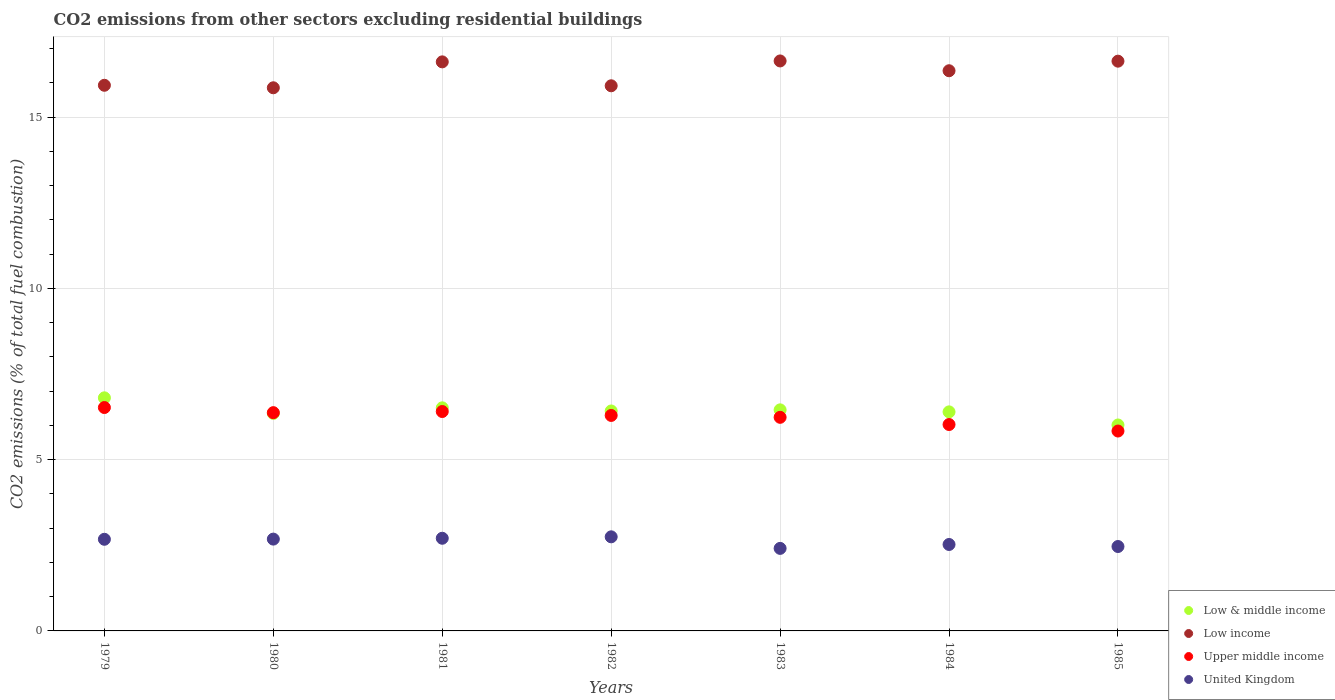How many different coloured dotlines are there?
Your answer should be very brief. 4. What is the total CO2 emitted in Low income in 1979?
Your response must be concise. 15.93. Across all years, what is the maximum total CO2 emitted in Upper middle income?
Your response must be concise. 6.52. Across all years, what is the minimum total CO2 emitted in Upper middle income?
Offer a very short reply. 5.84. In which year was the total CO2 emitted in Low & middle income maximum?
Keep it short and to the point. 1979. What is the total total CO2 emitted in United Kingdom in the graph?
Keep it short and to the point. 18.21. What is the difference between the total CO2 emitted in Low income in 1981 and that in 1985?
Offer a very short reply. -0.02. What is the difference between the total CO2 emitted in Low & middle income in 1983 and the total CO2 emitted in Low income in 1981?
Provide a succinct answer. -10.16. What is the average total CO2 emitted in Low income per year?
Offer a very short reply. 16.28. In the year 1985, what is the difference between the total CO2 emitted in Low income and total CO2 emitted in United Kingdom?
Your answer should be compact. 14.17. What is the ratio of the total CO2 emitted in United Kingdom in 1981 to that in 1983?
Provide a short and direct response. 1.12. Is the difference between the total CO2 emitted in Low income in 1980 and 1985 greater than the difference between the total CO2 emitted in United Kingdom in 1980 and 1985?
Provide a succinct answer. No. What is the difference between the highest and the second highest total CO2 emitted in Low income?
Ensure brevity in your answer.  0.01. What is the difference between the highest and the lowest total CO2 emitted in Low & middle income?
Offer a very short reply. 0.79. In how many years, is the total CO2 emitted in Low income greater than the average total CO2 emitted in Low income taken over all years?
Ensure brevity in your answer.  4. Is the sum of the total CO2 emitted in Low & middle income in 1980 and 1981 greater than the maximum total CO2 emitted in Low income across all years?
Provide a succinct answer. No. Does the total CO2 emitted in Low income monotonically increase over the years?
Provide a succinct answer. No. How many legend labels are there?
Give a very brief answer. 4. What is the title of the graph?
Provide a succinct answer. CO2 emissions from other sectors excluding residential buildings. Does "Croatia" appear as one of the legend labels in the graph?
Offer a very short reply. No. What is the label or title of the Y-axis?
Ensure brevity in your answer.  CO2 emissions (% of total fuel combustion). What is the CO2 emissions (% of total fuel combustion) of Low & middle income in 1979?
Ensure brevity in your answer.  6.81. What is the CO2 emissions (% of total fuel combustion) of Low income in 1979?
Your answer should be compact. 15.93. What is the CO2 emissions (% of total fuel combustion) of Upper middle income in 1979?
Your response must be concise. 6.52. What is the CO2 emissions (% of total fuel combustion) in United Kingdom in 1979?
Offer a terse response. 2.68. What is the CO2 emissions (% of total fuel combustion) of Low & middle income in 1980?
Give a very brief answer. 6.35. What is the CO2 emissions (% of total fuel combustion) of Low income in 1980?
Keep it short and to the point. 15.86. What is the CO2 emissions (% of total fuel combustion) of Upper middle income in 1980?
Keep it short and to the point. 6.37. What is the CO2 emissions (% of total fuel combustion) in United Kingdom in 1980?
Keep it short and to the point. 2.68. What is the CO2 emissions (% of total fuel combustion) in Low & middle income in 1981?
Your answer should be very brief. 6.51. What is the CO2 emissions (% of total fuel combustion) in Low income in 1981?
Offer a terse response. 16.62. What is the CO2 emissions (% of total fuel combustion) in Upper middle income in 1981?
Your answer should be very brief. 6.41. What is the CO2 emissions (% of total fuel combustion) of United Kingdom in 1981?
Offer a terse response. 2.71. What is the CO2 emissions (% of total fuel combustion) in Low & middle income in 1982?
Keep it short and to the point. 6.42. What is the CO2 emissions (% of total fuel combustion) in Low income in 1982?
Your response must be concise. 15.92. What is the CO2 emissions (% of total fuel combustion) in Upper middle income in 1982?
Your answer should be compact. 6.29. What is the CO2 emissions (% of total fuel combustion) of United Kingdom in 1982?
Provide a short and direct response. 2.75. What is the CO2 emissions (% of total fuel combustion) of Low & middle income in 1983?
Make the answer very short. 6.46. What is the CO2 emissions (% of total fuel combustion) in Low income in 1983?
Keep it short and to the point. 16.64. What is the CO2 emissions (% of total fuel combustion) of Upper middle income in 1983?
Make the answer very short. 6.24. What is the CO2 emissions (% of total fuel combustion) of United Kingdom in 1983?
Your answer should be compact. 2.41. What is the CO2 emissions (% of total fuel combustion) in Low & middle income in 1984?
Provide a short and direct response. 6.4. What is the CO2 emissions (% of total fuel combustion) of Low income in 1984?
Your answer should be compact. 16.36. What is the CO2 emissions (% of total fuel combustion) in Upper middle income in 1984?
Provide a succinct answer. 6.03. What is the CO2 emissions (% of total fuel combustion) of United Kingdom in 1984?
Your answer should be compact. 2.52. What is the CO2 emissions (% of total fuel combustion) in Low & middle income in 1985?
Your answer should be compact. 6.01. What is the CO2 emissions (% of total fuel combustion) in Low income in 1985?
Provide a succinct answer. 16.64. What is the CO2 emissions (% of total fuel combustion) in Upper middle income in 1985?
Provide a short and direct response. 5.84. What is the CO2 emissions (% of total fuel combustion) in United Kingdom in 1985?
Make the answer very short. 2.46. Across all years, what is the maximum CO2 emissions (% of total fuel combustion) in Low & middle income?
Provide a short and direct response. 6.81. Across all years, what is the maximum CO2 emissions (% of total fuel combustion) in Low income?
Provide a short and direct response. 16.64. Across all years, what is the maximum CO2 emissions (% of total fuel combustion) of Upper middle income?
Offer a terse response. 6.52. Across all years, what is the maximum CO2 emissions (% of total fuel combustion) in United Kingdom?
Your answer should be very brief. 2.75. Across all years, what is the minimum CO2 emissions (% of total fuel combustion) of Low & middle income?
Your response must be concise. 6.01. Across all years, what is the minimum CO2 emissions (% of total fuel combustion) of Low income?
Provide a succinct answer. 15.86. Across all years, what is the minimum CO2 emissions (% of total fuel combustion) of Upper middle income?
Make the answer very short. 5.84. Across all years, what is the minimum CO2 emissions (% of total fuel combustion) of United Kingdom?
Make the answer very short. 2.41. What is the total CO2 emissions (% of total fuel combustion) in Low & middle income in the graph?
Your answer should be compact. 44.96. What is the total CO2 emissions (% of total fuel combustion) of Low income in the graph?
Ensure brevity in your answer.  113.96. What is the total CO2 emissions (% of total fuel combustion) of Upper middle income in the graph?
Your answer should be very brief. 43.69. What is the total CO2 emissions (% of total fuel combustion) in United Kingdom in the graph?
Your answer should be very brief. 18.21. What is the difference between the CO2 emissions (% of total fuel combustion) in Low & middle income in 1979 and that in 1980?
Your response must be concise. 0.45. What is the difference between the CO2 emissions (% of total fuel combustion) of Low income in 1979 and that in 1980?
Your response must be concise. 0.07. What is the difference between the CO2 emissions (% of total fuel combustion) in Upper middle income in 1979 and that in 1980?
Provide a short and direct response. 0.15. What is the difference between the CO2 emissions (% of total fuel combustion) in United Kingdom in 1979 and that in 1980?
Give a very brief answer. -0.01. What is the difference between the CO2 emissions (% of total fuel combustion) in Low & middle income in 1979 and that in 1981?
Offer a terse response. 0.29. What is the difference between the CO2 emissions (% of total fuel combustion) in Low income in 1979 and that in 1981?
Your answer should be compact. -0.68. What is the difference between the CO2 emissions (% of total fuel combustion) of Upper middle income in 1979 and that in 1981?
Offer a terse response. 0.12. What is the difference between the CO2 emissions (% of total fuel combustion) in United Kingdom in 1979 and that in 1981?
Provide a short and direct response. -0.03. What is the difference between the CO2 emissions (% of total fuel combustion) of Low & middle income in 1979 and that in 1982?
Offer a terse response. 0.38. What is the difference between the CO2 emissions (% of total fuel combustion) in Low income in 1979 and that in 1982?
Provide a short and direct response. 0.01. What is the difference between the CO2 emissions (% of total fuel combustion) of Upper middle income in 1979 and that in 1982?
Offer a terse response. 0.23. What is the difference between the CO2 emissions (% of total fuel combustion) of United Kingdom in 1979 and that in 1982?
Provide a succinct answer. -0.07. What is the difference between the CO2 emissions (% of total fuel combustion) of Low & middle income in 1979 and that in 1983?
Provide a succinct answer. 0.35. What is the difference between the CO2 emissions (% of total fuel combustion) of Low income in 1979 and that in 1983?
Give a very brief answer. -0.71. What is the difference between the CO2 emissions (% of total fuel combustion) of Upper middle income in 1979 and that in 1983?
Your response must be concise. 0.29. What is the difference between the CO2 emissions (% of total fuel combustion) in United Kingdom in 1979 and that in 1983?
Offer a terse response. 0.27. What is the difference between the CO2 emissions (% of total fuel combustion) in Low & middle income in 1979 and that in 1984?
Your answer should be compact. 0.41. What is the difference between the CO2 emissions (% of total fuel combustion) in Low income in 1979 and that in 1984?
Offer a very short reply. -0.42. What is the difference between the CO2 emissions (% of total fuel combustion) of Upper middle income in 1979 and that in 1984?
Provide a succinct answer. 0.5. What is the difference between the CO2 emissions (% of total fuel combustion) of United Kingdom in 1979 and that in 1984?
Make the answer very short. 0.15. What is the difference between the CO2 emissions (% of total fuel combustion) in Low & middle income in 1979 and that in 1985?
Offer a terse response. 0.79. What is the difference between the CO2 emissions (% of total fuel combustion) in Low income in 1979 and that in 1985?
Offer a terse response. -0.7. What is the difference between the CO2 emissions (% of total fuel combustion) of Upper middle income in 1979 and that in 1985?
Provide a succinct answer. 0.69. What is the difference between the CO2 emissions (% of total fuel combustion) in United Kingdom in 1979 and that in 1985?
Provide a short and direct response. 0.21. What is the difference between the CO2 emissions (% of total fuel combustion) of Low & middle income in 1980 and that in 1981?
Ensure brevity in your answer.  -0.16. What is the difference between the CO2 emissions (% of total fuel combustion) of Low income in 1980 and that in 1981?
Your answer should be compact. -0.76. What is the difference between the CO2 emissions (% of total fuel combustion) in Upper middle income in 1980 and that in 1981?
Make the answer very short. -0.03. What is the difference between the CO2 emissions (% of total fuel combustion) of United Kingdom in 1980 and that in 1981?
Keep it short and to the point. -0.02. What is the difference between the CO2 emissions (% of total fuel combustion) of Low & middle income in 1980 and that in 1982?
Keep it short and to the point. -0.07. What is the difference between the CO2 emissions (% of total fuel combustion) of Low income in 1980 and that in 1982?
Offer a very short reply. -0.06. What is the difference between the CO2 emissions (% of total fuel combustion) in Upper middle income in 1980 and that in 1982?
Give a very brief answer. 0.08. What is the difference between the CO2 emissions (% of total fuel combustion) of United Kingdom in 1980 and that in 1982?
Give a very brief answer. -0.07. What is the difference between the CO2 emissions (% of total fuel combustion) of Low & middle income in 1980 and that in 1983?
Offer a terse response. -0.1. What is the difference between the CO2 emissions (% of total fuel combustion) of Low income in 1980 and that in 1983?
Your response must be concise. -0.78. What is the difference between the CO2 emissions (% of total fuel combustion) of Upper middle income in 1980 and that in 1983?
Your answer should be compact. 0.14. What is the difference between the CO2 emissions (% of total fuel combustion) of United Kingdom in 1980 and that in 1983?
Offer a terse response. 0.27. What is the difference between the CO2 emissions (% of total fuel combustion) in Low & middle income in 1980 and that in 1984?
Give a very brief answer. -0.04. What is the difference between the CO2 emissions (% of total fuel combustion) in Low income in 1980 and that in 1984?
Your response must be concise. -0.5. What is the difference between the CO2 emissions (% of total fuel combustion) in Upper middle income in 1980 and that in 1984?
Give a very brief answer. 0.35. What is the difference between the CO2 emissions (% of total fuel combustion) in United Kingdom in 1980 and that in 1984?
Ensure brevity in your answer.  0.16. What is the difference between the CO2 emissions (% of total fuel combustion) of Low & middle income in 1980 and that in 1985?
Your answer should be compact. 0.34. What is the difference between the CO2 emissions (% of total fuel combustion) of Low income in 1980 and that in 1985?
Ensure brevity in your answer.  -0.78. What is the difference between the CO2 emissions (% of total fuel combustion) in Upper middle income in 1980 and that in 1985?
Ensure brevity in your answer.  0.54. What is the difference between the CO2 emissions (% of total fuel combustion) in United Kingdom in 1980 and that in 1985?
Make the answer very short. 0.22. What is the difference between the CO2 emissions (% of total fuel combustion) in Low & middle income in 1981 and that in 1982?
Offer a terse response. 0.09. What is the difference between the CO2 emissions (% of total fuel combustion) in Low income in 1981 and that in 1982?
Give a very brief answer. 0.7. What is the difference between the CO2 emissions (% of total fuel combustion) in Upper middle income in 1981 and that in 1982?
Your answer should be very brief. 0.11. What is the difference between the CO2 emissions (% of total fuel combustion) in United Kingdom in 1981 and that in 1982?
Keep it short and to the point. -0.04. What is the difference between the CO2 emissions (% of total fuel combustion) of Low & middle income in 1981 and that in 1983?
Provide a succinct answer. 0.06. What is the difference between the CO2 emissions (% of total fuel combustion) in Low income in 1981 and that in 1983?
Give a very brief answer. -0.03. What is the difference between the CO2 emissions (% of total fuel combustion) in Upper middle income in 1981 and that in 1983?
Make the answer very short. 0.17. What is the difference between the CO2 emissions (% of total fuel combustion) in United Kingdom in 1981 and that in 1983?
Give a very brief answer. 0.3. What is the difference between the CO2 emissions (% of total fuel combustion) of Low & middle income in 1981 and that in 1984?
Offer a terse response. 0.12. What is the difference between the CO2 emissions (% of total fuel combustion) in Low income in 1981 and that in 1984?
Provide a succinct answer. 0.26. What is the difference between the CO2 emissions (% of total fuel combustion) in Upper middle income in 1981 and that in 1984?
Provide a succinct answer. 0.38. What is the difference between the CO2 emissions (% of total fuel combustion) of United Kingdom in 1981 and that in 1984?
Your response must be concise. 0.18. What is the difference between the CO2 emissions (% of total fuel combustion) of Low & middle income in 1981 and that in 1985?
Provide a succinct answer. 0.5. What is the difference between the CO2 emissions (% of total fuel combustion) in Low income in 1981 and that in 1985?
Your response must be concise. -0.02. What is the difference between the CO2 emissions (% of total fuel combustion) in Upper middle income in 1981 and that in 1985?
Your answer should be compact. 0.57. What is the difference between the CO2 emissions (% of total fuel combustion) in United Kingdom in 1981 and that in 1985?
Offer a terse response. 0.24. What is the difference between the CO2 emissions (% of total fuel combustion) in Low & middle income in 1982 and that in 1983?
Provide a succinct answer. -0.03. What is the difference between the CO2 emissions (% of total fuel combustion) in Low income in 1982 and that in 1983?
Provide a succinct answer. -0.73. What is the difference between the CO2 emissions (% of total fuel combustion) in Upper middle income in 1982 and that in 1983?
Make the answer very short. 0.06. What is the difference between the CO2 emissions (% of total fuel combustion) of United Kingdom in 1982 and that in 1983?
Offer a very short reply. 0.34. What is the difference between the CO2 emissions (% of total fuel combustion) of Low & middle income in 1982 and that in 1984?
Give a very brief answer. 0.03. What is the difference between the CO2 emissions (% of total fuel combustion) of Low income in 1982 and that in 1984?
Provide a short and direct response. -0.44. What is the difference between the CO2 emissions (% of total fuel combustion) of Upper middle income in 1982 and that in 1984?
Provide a short and direct response. 0.27. What is the difference between the CO2 emissions (% of total fuel combustion) in United Kingdom in 1982 and that in 1984?
Provide a succinct answer. 0.22. What is the difference between the CO2 emissions (% of total fuel combustion) of Low & middle income in 1982 and that in 1985?
Offer a very short reply. 0.41. What is the difference between the CO2 emissions (% of total fuel combustion) in Low income in 1982 and that in 1985?
Your answer should be very brief. -0.72. What is the difference between the CO2 emissions (% of total fuel combustion) in Upper middle income in 1982 and that in 1985?
Give a very brief answer. 0.46. What is the difference between the CO2 emissions (% of total fuel combustion) in United Kingdom in 1982 and that in 1985?
Provide a short and direct response. 0.28. What is the difference between the CO2 emissions (% of total fuel combustion) in Low & middle income in 1983 and that in 1984?
Your answer should be very brief. 0.06. What is the difference between the CO2 emissions (% of total fuel combustion) in Low income in 1983 and that in 1984?
Keep it short and to the point. 0.29. What is the difference between the CO2 emissions (% of total fuel combustion) of Upper middle income in 1983 and that in 1984?
Make the answer very short. 0.21. What is the difference between the CO2 emissions (% of total fuel combustion) of United Kingdom in 1983 and that in 1984?
Make the answer very short. -0.11. What is the difference between the CO2 emissions (% of total fuel combustion) in Low & middle income in 1983 and that in 1985?
Give a very brief answer. 0.44. What is the difference between the CO2 emissions (% of total fuel combustion) of Low income in 1983 and that in 1985?
Provide a short and direct response. 0.01. What is the difference between the CO2 emissions (% of total fuel combustion) in Upper middle income in 1983 and that in 1985?
Offer a terse response. 0.4. What is the difference between the CO2 emissions (% of total fuel combustion) in United Kingdom in 1983 and that in 1985?
Offer a very short reply. -0.05. What is the difference between the CO2 emissions (% of total fuel combustion) of Low & middle income in 1984 and that in 1985?
Provide a succinct answer. 0.38. What is the difference between the CO2 emissions (% of total fuel combustion) of Low income in 1984 and that in 1985?
Keep it short and to the point. -0.28. What is the difference between the CO2 emissions (% of total fuel combustion) of Upper middle income in 1984 and that in 1985?
Provide a short and direct response. 0.19. What is the difference between the CO2 emissions (% of total fuel combustion) of United Kingdom in 1984 and that in 1985?
Keep it short and to the point. 0.06. What is the difference between the CO2 emissions (% of total fuel combustion) of Low & middle income in 1979 and the CO2 emissions (% of total fuel combustion) of Low income in 1980?
Make the answer very short. -9.05. What is the difference between the CO2 emissions (% of total fuel combustion) of Low & middle income in 1979 and the CO2 emissions (% of total fuel combustion) of Upper middle income in 1980?
Your answer should be compact. 0.43. What is the difference between the CO2 emissions (% of total fuel combustion) of Low & middle income in 1979 and the CO2 emissions (% of total fuel combustion) of United Kingdom in 1980?
Your answer should be compact. 4.13. What is the difference between the CO2 emissions (% of total fuel combustion) in Low income in 1979 and the CO2 emissions (% of total fuel combustion) in Upper middle income in 1980?
Give a very brief answer. 9.56. What is the difference between the CO2 emissions (% of total fuel combustion) of Low income in 1979 and the CO2 emissions (% of total fuel combustion) of United Kingdom in 1980?
Ensure brevity in your answer.  13.25. What is the difference between the CO2 emissions (% of total fuel combustion) in Upper middle income in 1979 and the CO2 emissions (% of total fuel combustion) in United Kingdom in 1980?
Give a very brief answer. 3.84. What is the difference between the CO2 emissions (% of total fuel combustion) of Low & middle income in 1979 and the CO2 emissions (% of total fuel combustion) of Low income in 1981?
Your answer should be compact. -9.81. What is the difference between the CO2 emissions (% of total fuel combustion) in Low & middle income in 1979 and the CO2 emissions (% of total fuel combustion) in Upper middle income in 1981?
Keep it short and to the point. 0.4. What is the difference between the CO2 emissions (% of total fuel combustion) of Low & middle income in 1979 and the CO2 emissions (% of total fuel combustion) of United Kingdom in 1981?
Keep it short and to the point. 4.1. What is the difference between the CO2 emissions (% of total fuel combustion) in Low income in 1979 and the CO2 emissions (% of total fuel combustion) in Upper middle income in 1981?
Give a very brief answer. 9.53. What is the difference between the CO2 emissions (% of total fuel combustion) of Low income in 1979 and the CO2 emissions (% of total fuel combustion) of United Kingdom in 1981?
Your answer should be compact. 13.23. What is the difference between the CO2 emissions (% of total fuel combustion) of Upper middle income in 1979 and the CO2 emissions (% of total fuel combustion) of United Kingdom in 1981?
Offer a very short reply. 3.82. What is the difference between the CO2 emissions (% of total fuel combustion) of Low & middle income in 1979 and the CO2 emissions (% of total fuel combustion) of Low income in 1982?
Provide a short and direct response. -9.11. What is the difference between the CO2 emissions (% of total fuel combustion) in Low & middle income in 1979 and the CO2 emissions (% of total fuel combustion) in Upper middle income in 1982?
Keep it short and to the point. 0.51. What is the difference between the CO2 emissions (% of total fuel combustion) of Low & middle income in 1979 and the CO2 emissions (% of total fuel combustion) of United Kingdom in 1982?
Provide a succinct answer. 4.06. What is the difference between the CO2 emissions (% of total fuel combustion) of Low income in 1979 and the CO2 emissions (% of total fuel combustion) of Upper middle income in 1982?
Offer a terse response. 9.64. What is the difference between the CO2 emissions (% of total fuel combustion) of Low income in 1979 and the CO2 emissions (% of total fuel combustion) of United Kingdom in 1982?
Provide a succinct answer. 13.18. What is the difference between the CO2 emissions (% of total fuel combustion) in Upper middle income in 1979 and the CO2 emissions (% of total fuel combustion) in United Kingdom in 1982?
Your answer should be compact. 3.78. What is the difference between the CO2 emissions (% of total fuel combustion) in Low & middle income in 1979 and the CO2 emissions (% of total fuel combustion) in Low income in 1983?
Your answer should be compact. -9.84. What is the difference between the CO2 emissions (% of total fuel combustion) of Low & middle income in 1979 and the CO2 emissions (% of total fuel combustion) of Upper middle income in 1983?
Your response must be concise. 0.57. What is the difference between the CO2 emissions (% of total fuel combustion) of Low & middle income in 1979 and the CO2 emissions (% of total fuel combustion) of United Kingdom in 1983?
Your answer should be compact. 4.4. What is the difference between the CO2 emissions (% of total fuel combustion) of Low income in 1979 and the CO2 emissions (% of total fuel combustion) of Upper middle income in 1983?
Provide a succinct answer. 9.7. What is the difference between the CO2 emissions (% of total fuel combustion) of Low income in 1979 and the CO2 emissions (% of total fuel combustion) of United Kingdom in 1983?
Offer a terse response. 13.52. What is the difference between the CO2 emissions (% of total fuel combustion) in Upper middle income in 1979 and the CO2 emissions (% of total fuel combustion) in United Kingdom in 1983?
Your answer should be compact. 4.11. What is the difference between the CO2 emissions (% of total fuel combustion) in Low & middle income in 1979 and the CO2 emissions (% of total fuel combustion) in Low income in 1984?
Keep it short and to the point. -9.55. What is the difference between the CO2 emissions (% of total fuel combustion) of Low & middle income in 1979 and the CO2 emissions (% of total fuel combustion) of Upper middle income in 1984?
Provide a short and direct response. 0.78. What is the difference between the CO2 emissions (% of total fuel combustion) in Low & middle income in 1979 and the CO2 emissions (% of total fuel combustion) in United Kingdom in 1984?
Your response must be concise. 4.28. What is the difference between the CO2 emissions (% of total fuel combustion) in Low income in 1979 and the CO2 emissions (% of total fuel combustion) in Upper middle income in 1984?
Offer a terse response. 9.91. What is the difference between the CO2 emissions (% of total fuel combustion) in Low income in 1979 and the CO2 emissions (% of total fuel combustion) in United Kingdom in 1984?
Provide a short and direct response. 13.41. What is the difference between the CO2 emissions (% of total fuel combustion) in Upper middle income in 1979 and the CO2 emissions (% of total fuel combustion) in United Kingdom in 1984?
Offer a terse response. 4. What is the difference between the CO2 emissions (% of total fuel combustion) in Low & middle income in 1979 and the CO2 emissions (% of total fuel combustion) in Low income in 1985?
Make the answer very short. -9.83. What is the difference between the CO2 emissions (% of total fuel combustion) of Low & middle income in 1979 and the CO2 emissions (% of total fuel combustion) of Upper middle income in 1985?
Keep it short and to the point. 0.97. What is the difference between the CO2 emissions (% of total fuel combustion) of Low & middle income in 1979 and the CO2 emissions (% of total fuel combustion) of United Kingdom in 1985?
Offer a very short reply. 4.34. What is the difference between the CO2 emissions (% of total fuel combustion) in Low income in 1979 and the CO2 emissions (% of total fuel combustion) in Upper middle income in 1985?
Offer a very short reply. 10.1. What is the difference between the CO2 emissions (% of total fuel combustion) of Low income in 1979 and the CO2 emissions (% of total fuel combustion) of United Kingdom in 1985?
Keep it short and to the point. 13.47. What is the difference between the CO2 emissions (% of total fuel combustion) in Upper middle income in 1979 and the CO2 emissions (% of total fuel combustion) in United Kingdom in 1985?
Make the answer very short. 4.06. What is the difference between the CO2 emissions (% of total fuel combustion) of Low & middle income in 1980 and the CO2 emissions (% of total fuel combustion) of Low income in 1981?
Your response must be concise. -10.26. What is the difference between the CO2 emissions (% of total fuel combustion) of Low & middle income in 1980 and the CO2 emissions (% of total fuel combustion) of Upper middle income in 1981?
Give a very brief answer. -0.05. What is the difference between the CO2 emissions (% of total fuel combustion) of Low & middle income in 1980 and the CO2 emissions (% of total fuel combustion) of United Kingdom in 1981?
Provide a short and direct response. 3.65. What is the difference between the CO2 emissions (% of total fuel combustion) of Low income in 1980 and the CO2 emissions (% of total fuel combustion) of Upper middle income in 1981?
Your answer should be compact. 9.45. What is the difference between the CO2 emissions (% of total fuel combustion) in Low income in 1980 and the CO2 emissions (% of total fuel combustion) in United Kingdom in 1981?
Your response must be concise. 13.15. What is the difference between the CO2 emissions (% of total fuel combustion) in Upper middle income in 1980 and the CO2 emissions (% of total fuel combustion) in United Kingdom in 1981?
Your response must be concise. 3.67. What is the difference between the CO2 emissions (% of total fuel combustion) of Low & middle income in 1980 and the CO2 emissions (% of total fuel combustion) of Low income in 1982?
Your response must be concise. -9.57. What is the difference between the CO2 emissions (% of total fuel combustion) in Low & middle income in 1980 and the CO2 emissions (% of total fuel combustion) in Upper middle income in 1982?
Provide a short and direct response. 0.06. What is the difference between the CO2 emissions (% of total fuel combustion) of Low & middle income in 1980 and the CO2 emissions (% of total fuel combustion) of United Kingdom in 1982?
Your answer should be very brief. 3.6. What is the difference between the CO2 emissions (% of total fuel combustion) in Low income in 1980 and the CO2 emissions (% of total fuel combustion) in Upper middle income in 1982?
Offer a terse response. 9.57. What is the difference between the CO2 emissions (% of total fuel combustion) of Low income in 1980 and the CO2 emissions (% of total fuel combustion) of United Kingdom in 1982?
Keep it short and to the point. 13.11. What is the difference between the CO2 emissions (% of total fuel combustion) in Upper middle income in 1980 and the CO2 emissions (% of total fuel combustion) in United Kingdom in 1982?
Give a very brief answer. 3.63. What is the difference between the CO2 emissions (% of total fuel combustion) in Low & middle income in 1980 and the CO2 emissions (% of total fuel combustion) in Low income in 1983?
Your response must be concise. -10.29. What is the difference between the CO2 emissions (% of total fuel combustion) of Low & middle income in 1980 and the CO2 emissions (% of total fuel combustion) of Upper middle income in 1983?
Provide a succinct answer. 0.11. What is the difference between the CO2 emissions (% of total fuel combustion) of Low & middle income in 1980 and the CO2 emissions (% of total fuel combustion) of United Kingdom in 1983?
Provide a succinct answer. 3.94. What is the difference between the CO2 emissions (% of total fuel combustion) of Low income in 1980 and the CO2 emissions (% of total fuel combustion) of Upper middle income in 1983?
Provide a short and direct response. 9.62. What is the difference between the CO2 emissions (% of total fuel combustion) of Low income in 1980 and the CO2 emissions (% of total fuel combustion) of United Kingdom in 1983?
Provide a short and direct response. 13.45. What is the difference between the CO2 emissions (% of total fuel combustion) of Upper middle income in 1980 and the CO2 emissions (% of total fuel combustion) of United Kingdom in 1983?
Your response must be concise. 3.96. What is the difference between the CO2 emissions (% of total fuel combustion) of Low & middle income in 1980 and the CO2 emissions (% of total fuel combustion) of Low income in 1984?
Offer a very short reply. -10.01. What is the difference between the CO2 emissions (% of total fuel combustion) of Low & middle income in 1980 and the CO2 emissions (% of total fuel combustion) of Upper middle income in 1984?
Offer a very short reply. 0.32. What is the difference between the CO2 emissions (% of total fuel combustion) in Low & middle income in 1980 and the CO2 emissions (% of total fuel combustion) in United Kingdom in 1984?
Keep it short and to the point. 3.83. What is the difference between the CO2 emissions (% of total fuel combustion) in Low income in 1980 and the CO2 emissions (% of total fuel combustion) in Upper middle income in 1984?
Give a very brief answer. 9.83. What is the difference between the CO2 emissions (% of total fuel combustion) of Low income in 1980 and the CO2 emissions (% of total fuel combustion) of United Kingdom in 1984?
Offer a terse response. 13.33. What is the difference between the CO2 emissions (% of total fuel combustion) of Upper middle income in 1980 and the CO2 emissions (% of total fuel combustion) of United Kingdom in 1984?
Your answer should be compact. 3.85. What is the difference between the CO2 emissions (% of total fuel combustion) in Low & middle income in 1980 and the CO2 emissions (% of total fuel combustion) in Low income in 1985?
Ensure brevity in your answer.  -10.28. What is the difference between the CO2 emissions (% of total fuel combustion) of Low & middle income in 1980 and the CO2 emissions (% of total fuel combustion) of Upper middle income in 1985?
Give a very brief answer. 0.51. What is the difference between the CO2 emissions (% of total fuel combustion) of Low & middle income in 1980 and the CO2 emissions (% of total fuel combustion) of United Kingdom in 1985?
Keep it short and to the point. 3.89. What is the difference between the CO2 emissions (% of total fuel combustion) in Low income in 1980 and the CO2 emissions (% of total fuel combustion) in Upper middle income in 1985?
Make the answer very short. 10.02. What is the difference between the CO2 emissions (% of total fuel combustion) in Low income in 1980 and the CO2 emissions (% of total fuel combustion) in United Kingdom in 1985?
Keep it short and to the point. 13.39. What is the difference between the CO2 emissions (% of total fuel combustion) in Upper middle income in 1980 and the CO2 emissions (% of total fuel combustion) in United Kingdom in 1985?
Make the answer very short. 3.91. What is the difference between the CO2 emissions (% of total fuel combustion) of Low & middle income in 1981 and the CO2 emissions (% of total fuel combustion) of Low income in 1982?
Give a very brief answer. -9.4. What is the difference between the CO2 emissions (% of total fuel combustion) in Low & middle income in 1981 and the CO2 emissions (% of total fuel combustion) in Upper middle income in 1982?
Your response must be concise. 0.22. What is the difference between the CO2 emissions (% of total fuel combustion) of Low & middle income in 1981 and the CO2 emissions (% of total fuel combustion) of United Kingdom in 1982?
Your response must be concise. 3.77. What is the difference between the CO2 emissions (% of total fuel combustion) of Low income in 1981 and the CO2 emissions (% of total fuel combustion) of Upper middle income in 1982?
Your answer should be compact. 10.32. What is the difference between the CO2 emissions (% of total fuel combustion) of Low income in 1981 and the CO2 emissions (% of total fuel combustion) of United Kingdom in 1982?
Your answer should be very brief. 13.87. What is the difference between the CO2 emissions (% of total fuel combustion) in Upper middle income in 1981 and the CO2 emissions (% of total fuel combustion) in United Kingdom in 1982?
Make the answer very short. 3.66. What is the difference between the CO2 emissions (% of total fuel combustion) of Low & middle income in 1981 and the CO2 emissions (% of total fuel combustion) of Low income in 1983?
Your answer should be compact. -10.13. What is the difference between the CO2 emissions (% of total fuel combustion) in Low & middle income in 1981 and the CO2 emissions (% of total fuel combustion) in Upper middle income in 1983?
Your response must be concise. 0.28. What is the difference between the CO2 emissions (% of total fuel combustion) in Low & middle income in 1981 and the CO2 emissions (% of total fuel combustion) in United Kingdom in 1983?
Offer a very short reply. 4.1. What is the difference between the CO2 emissions (% of total fuel combustion) in Low income in 1981 and the CO2 emissions (% of total fuel combustion) in Upper middle income in 1983?
Give a very brief answer. 10.38. What is the difference between the CO2 emissions (% of total fuel combustion) in Low income in 1981 and the CO2 emissions (% of total fuel combustion) in United Kingdom in 1983?
Your response must be concise. 14.21. What is the difference between the CO2 emissions (% of total fuel combustion) of Upper middle income in 1981 and the CO2 emissions (% of total fuel combustion) of United Kingdom in 1983?
Ensure brevity in your answer.  4. What is the difference between the CO2 emissions (% of total fuel combustion) in Low & middle income in 1981 and the CO2 emissions (% of total fuel combustion) in Low income in 1984?
Your response must be concise. -9.84. What is the difference between the CO2 emissions (% of total fuel combustion) of Low & middle income in 1981 and the CO2 emissions (% of total fuel combustion) of Upper middle income in 1984?
Offer a terse response. 0.49. What is the difference between the CO2 emissions (% of total fuel combustion) in Low & middle income in 1981 and the CO2 emissions (% of total fuel combustion) in United Kingdom in 1984?
Your response must be concise. 3.99. What is the difference between the CO2 emissions (% of total fuel combustion) in Low income in 1981 and the CO2 emissions (% of total fuel combustion) in Upper middle income in 1984?
Make the answer very short. 10.59. What is the difference between the CO2 emissions (% of total fuel combustion) in Low income in 1981 and the CO2 emissions (% of total fuel combustion) in United Kingdom in 1984?
Give a very brief answer. 14.09. What is the difference between the CO2 emissions (% of total fuel combustion) in Upper middle income in 1981 and the CO2 emissions (% of total fuel combustion) in United Kingdom in 1984?
Your answer should be very brief. 3.88. What is the difference between the CO2 emissions (% of total fuel combustion) in Low & middle income in 1981 and the CO2 emissions (% of total fuel combustion) in Low income in 1985?
Keep it short and to the point. -10.12. What is the difference between the CO2 emissions (% of total fuel combustion) in Low & middle income in 1981 and the CO2 emissions (% of total fuel combustion) in Upper middle income in 1985?
Provide a succinct answer. 0.68. What is the difference between the CO2 emissions (% of total fuel combustion) in Low & middle income in 1981 and the CO2 emissions (% of total fuel combustion) in United Kingdom in 1985?
Your response must be concise. 4.05. What is the difference between the CO2 emissions (% of total fuel combustion) of Low income in 1981 and the CO2 emissions (% of total fuel combustion) of Upper middle income in 1985?
Give a very brief answer. 10.78. What is the difference between the CO2 emissions (% of total fuel combustion) in Low income in 1981 and the CO2 emissions (% of total fuel combustion) in United Kingdom in 1985?
Make the answer very short. 14.15. What is the difference between the CO2 emissions (% of total fuel combustion) of Upper middle income in 1981 and the CO2 emissions (% of total fuel combustion) of United Kingdom in 1985?
Make the answer very short. 3.94. What is the difference between the CO2 emissions (% of total fuel combustion) of Low & middle income in 1982 and the CO2 emissions (% of total fuel combustion) of Low income in 1983?
Your answer should be compact. -10.22. What is the difference between the CO2 emissions (% of total fuel combustion) of Low & middle income in 1982 and the CO2 emissions (% of total fuel combustion) of Upper middle income in 1983?
Offer a very short reply. 0.19. What is the difference between the CO2 emissions (% of total fuel combustion) in Low & middle income in 1982 and the CO2 emissions (% of total fuel combustion) in United Kingdom in 1983?
Offer a terse response. 4.01. What is the difference between the CO2 emissions (% of total fuel combustion) in Low income in 1982 and the CO2 emissions (% of total fuel combustion) in Upper middle income in 1983?
Your answer should be compact. 9.68. What is the difference between the CO2 emissions (% of total fuel combustion) of Low income in 1982 and the CO2 emissions (% of total fuel combustion) of United Kingdom in 1983?
Ensure brevity in your answer.  13.51. What is the difference between the CO2 emissions (% of total fuel combustion) of Upper middle income in 1982 and the CO2 emissions (% of total fuel combustion) of United Kingdom in 1983?
Give a very brief answer. 3.88. What is the difference between the CO2 emissions (% of total fuel combustion) of Low & middle income in 1982 and the CO2 emissions (% of total fuel combustion) of Low income in 1984?
Provide a succinct answer. -9.93. What is the difference between the CO2 emissions (% of total fuel combustion) of Low & middle income in 1982 and the CO2 emissions (% of total fuel combustion) of Upper middle income in 1984?
Make the answer very short. 0.4. What is the difference between the CO2 emissions (% of total fuel combustion) of Low & middle income in 1982 and the CO2 emissions (% of total fuel combustion) of United Kingdom in 1984?
Your answer should be compact. 3.9. What is the difference between the CO2 emissions (% of total fuel combustion) in Low income in 1982 and the CO2 emissions (% of total fuel combustion) in Upper middle income in 1984?
Offer a terse response. 9.89. What is the difference between the CO2 emissions (% of total fuel combustion) in Low income in 1982 and the CO2 emissions (% of total fuel combustion) in United Kingdom in 1984?
Your answer should be very brief. 13.39. What is the difference between the CO2 emissions (% of total fuel combustion) in Upper middle income in 1982 and the CO2 emissions (% of total fuel combustion) in United Kingdom in 1984?
Your answer should be compact. 3.77. What is the difference between the CO2 emissions (% of total fuel combustion) of Low & middle income in 1982 and the CO2 emissions (% of total fuel combustion) of Low income in 1985?
Provide a succinct answer. -10.21. What is the difference between the CO2 emissions (% of total fuel combustion) in Low & middle income in 1982 and the CO2 emissions (% of total fuel combustion) in Upper middle income in 1985?
Give a very brief answer. 0.59. What is the difference between the CO2 emissions (% of total fuel combustion) of Low & middle income in 1982 and the CO2 emissions (% of total fuel combustion) of United Kingdom in 1985?
Provide a short and direct response. 3.96. What is the difference between the CO2 emissions (% of total fuel combustion) in Low income in 1982 and the CO2 emissions (% of total fuel combustion) in Upper middle income in 1985?
Offer a very short reply. 10.08. What is the difference between the CO2 emissions (% of total fuel combustion) in Low income in 1982 and the CO2 emissions (% of total fuel combustion) in United Kingdom in 1985?
Make the answer very short. 13.45. What is the difference between the CO2 emissions (% of total fuel combustion) in Upper middle income in 1982 and the CO2 emissions (% of total fuel combustion) in United Kingdom in 1985?
Your answer should be very brief. 3.83. What is the difference between the CO2 emissions (% of total fuel combustion) of Low & middle income in 1983 and the CO2 emissions (% of total fuel combustion) of Low income in 1984?
Make the answer very short. -9.9. What is the difference between the CO2 emissions (% of total fuel combustion) in Low & middle income in 1983 and the CO2 emissions (% of total fuel combustion) in Upper middle income in 1984?
Your response must be concise. 0.43. What is the difference between the CO2 emissions (% of total fuel combustion) in Low & middle income in 1983 and the CO2 emissions (% of total fuel combustion) in United Kingdom in 1984?
Keep it short and to the point. 3.93. What is the difference between the CO2 emissions (% of total fuel combustion) of Low income in 1983 and the CO2 emissions (% of total fuel combustion) of Upper middle income in 1984?
Make the answer very short. 10.62. What is the difference between the CO2 emissions (% of total fuel combustion) of Low income in 1983 and the CO2 emissions (% of total fuel combustion) of United Kingdom in 1984?
Offer a terse response. 14.12. What is the difference between the CO2 emissions (% of total fuel combustion) of Upper middle income in 1983 and the CO2 emissions (% of total fuel combustion) of United Kingdom in 1984?
Provide a succinct answer. 3.71. What is the difference between the CO2 emissions (% of total fuel combustion) of Low & middle income in 1983 and the CO2 emissions (% of total fuel combustion) of Low income in 1985?
Keep it short and to the point. -10.18. What is the difference between the CO2 emissions (% of total fuel combustion) of Low & middle income in 1983 and the CO2 emissions (% of total fuel combustion) of Upper middle income in 1985?
Provide a short and direct response. 0.62. What is the difference between the CO2 emissions (% of total fuel combustion) in Low & middle income in 1983 and the CO2 emissions (% of total fuel combustion) in United Kingdom in 1985?
Keep it short and to the point. 3.99. What is the difference between the CO2 emissions (% of total fuel combustion) in Low income in 1983 and the CO2 emissions (% of total fuel combustion) in Upper middle income in 1985?
Give a very brief answer. 10.81. What is the difference between the CO2 emissions (% of total fuel combustion) in Low income in 1983 and the CO2 emissions (% of total fuel combustion) in United Kingdom in 1985?
Provide a succinct answer. 14.18. What is the difference between the CO2 emissions (% of total fuel combustion) of Upper middle income in 1983 and the CO2 emissions (% of total fuel combustion) of United Kingdom in 1985?
Offer a terse response. 3.77. What is the difference between the CO2 emissions (% of total fuel combustion) in Low & middle income in 1984 and the CO2 emissions (% of total fuel combustion) in Low income in 1985?
Offer a terse response. -10.24. What is the difference between the CO2 emissions (% of total fuel combustion) of Low & middle income in 1984 and the CO2 emissions (% of total fuel combustion) of Upper middle income in 1985?
Keep it short and to the point. 0.56. What is the difference between the CO2 emissions (% of total fuel combustion) in Low & middle income in 1984 and the CO2 emissions (% of total fuel combustion) in United Kingdom in 1985?
Give a very brief answer. 3.93. What is the difference between the CO2 emissions (% of total fuel combustion) in Low income in 1984 and the CO2 emissions (% of total fuel combustion) in Upper middle income in 1985?
Ensure brevity in your answer.  10.52. What is the difference between the CO2 emissions (% of total fuel combustion) in Low income in 1984 and the CO2 emissions (% of total fuel combustion) in United Kingdom in 1985?
Give a very brief answer. 13.89. What is the difference between the CO2 emissions (% of total fuel combustion) of Upper middle income in 1984 and the CO2 emissions (% of total fuel combustion) of United Kingdom in 1985?
Ensure brevity in your answer.  3.56. What is the average CO2 emissions (% of total fuel combustion) of Low & middle income per year?
Provide a short and direct response. 6.42. What is the average CO2 emissions (% of total fuel combustion) in Low income per year?
Your answer should be very brief. 16.28. What is the average CO2 emissions (% of total fuel combustion) in Upper middle income per year?
Make the answer very short. 6.24. What is the average CO2 emissions (% of total fuel combustion) of United Kingdom per year?
Provide a short and direct response. 2.6. In the year 1979, what is the difference between the CO2 emissions (% of total fuel combustion) in Low & middle income and CO2 emissions (% of total fuel combustion) in Low income?
Provide a succinct answer. -9.13. In the year 1979, what is the difference between the CO2 emissions (% of total fuel combustion) in Low & middle income and CO2 emissions (% of total fuel combustion) in Upper middle income?
Offer a terse response. 0.28. In the year 1979, what is the difference between the CO2 emissions (% of total fuel combustion) in Low & middle income and CO2 emissions (% of total fuel combustion) in United Kingdom?
Offer a terse response. 4.13. In the year 1979, what is the difference between the CO2 emissions (% of total fuel combustion) in Low income and CO2 emissions (% of total fuel combustion) in Upper middle income?
Keep it short and to the point. 9.41. In the year 1979, what is the difference between the CO2 emissions (% of total fuel combustion) of Low income and CO2 emissions (% of total fuel combustion) of United Kingdom?
Give a very brief answer. 13.26. In the year 1979, what is the difference between the CO2 emissions (% of total fuel combustion) in Upper middle income and CO2 emissions (% of total fuel combustion) in United Kingdom?
Keep it short and to the point. 3.85. In the year 1980, what is the difference between the CO2 emissions (% of total fuel combustion) in Low & middle income and CO2 emissions (% of total fuel combustion) in Low income?
Offer a terse response. -9.51. In the year 1980, what is the difference between the CO2 emissions (% of total fuel combustion) of Low & middle income and CO2 emissions (% of total fuel combustion) of Upper middle income?
Provide a succinct answer. -0.02. In the year 1980, what is the difference between the CO2 emissions (% of total fuel combustion) of Low & middle income and CO2 emissions (% of total fuel combustion) of United Kingdom?
Offer a very short reply. 3.67. In the year 1980, what is the difference between the CO2 emissions (% of total fuel combustion) in Low income and CO2 emissions (% of total fuel combustion) in Upper middle income?
Offer a very short reply. 9.49. In the year 1980, what is the difference between the CO2 emissions (% of total fuel combustion) of Low income and CO2 emissions (% of total fuel combustion) of United Kingdom?
Offer a terse response. 13.18. In the year 1980, what is the difference between the CO2 emissions (% of total fuel combustion) in Upper middle income and CO2 emissions (% of total fuel combustion) in United Kingdom?
Your response must be concise. 3.69. In the year 1981, what is the difference between the CO2 emissions (% of total fuel combustion) in Low & middle income and CO2 emissions (% of total fuel combustion) in Low income?
Provide a short and direct response. -10.1. In the year 1981, what is the difference between the CO2 emissions (% of total fuel combustion) of Low & middle income and CO2 emissions (% of total fuel combustion) of Upper middle income?
Make the answer very short. 0.11. In the year 1981, what is the difference between the CO2 emissions (% of total fuel combustion) in Low & middle income and CO2 emissions (% of total fuel combustion) in United Kingdom?
Your answer should be compact. 3.81. In the year 1981, what is the difference between the CO2 emissions (% of total fuel combustion) in Low income and CO2 emissions (% of total fuel combustion) in Upper middle income?
Your answer should be very brief. 10.21. In the year 1981, what is the difference between the CO2 emissions (% of total fuel combustion) in Low income and CO2 emissions (% of total fuel combustion) in United Kingdom?
Provide a succinct answer. 13.91. In the year 1981, what is the difference between the CO2 emissions (% of total fuel combustion) of Upper middle income and CO2 emissions (% of total fuel combustion) of United Kingdom?
Your answer should be compact. 3.7. In the year 1982, what is the difference between the CO2 emissions (% of total fuel combustion) of Low & middle income and CO2 emissions (% of total fuel combustion) of Low income?
Your answer should be compact. -9.49. In the year 1982, what is the difference between the CO2 emissions (% of total fuel combustion) in Low & middle income and CO2 emissions (% of total fuel combustion) in Upper middle income?
Provide a short and direct response. 0.13. In the year 1982, what is the difference between the CO2 emissions (% of total fuel combustion) of Low & middle income and CO2 emissions (% of total fuel combustion) of United Kingdom?
Give a very brief answer. 3.67. In the year 1982, what is the difference between the CO2 emissions (% of total fuel combustion) of Low income and CO2 emissions (% of total fuel combustion) of Upper middle income?
Offer a terse response. 9.63. In the year 1982, what is the difference between the CO2 emissions (% of total fuel combustion) in Low income and CO2 emissions (% of total fuel combustion) in United Kingdom?
Your answer should be very brief. 13.17. In the year 1982, what is the difference between the CO2 emissions (% of total fuel combustion) in Upper middle income and CO2 emissions (% of total fuel combustion) in United Kingdom?
Your response must be concise. 3.54. In the year 1983, what is the difference between the CO2 emissions (% of total fuel combustion) of Low & middle income and CO2 emissions (% of total fuel combustion) of Low income?
Offer a very short reply. -10.19. In the year 1983, what is the difference between the CO2 emissions (% of total fuel combustion) in Low & middle income and CO2 emissions (% of total fuel combustion) in Upper middle income?
Ensure brevity in your answer.  0.22. In the year 1983, what is the difference between the CO2 emissions (% of total fuel combustion) in Low & middle income and CO2 emissions (% of total fuel combustion) in United Kingdom?
Your answer should be very brief. 4.05. In the year 1983, what is the difference between the CO2 emissions (% of total fuel combustion) of Low income and CO2 emissions (% of total fuel combustion) of Upper middle income?
Provide a short and direct response. 10.41. In the year 1983, what is the difference between the CO2 emissions (% of total fuel combustion) in Low income and CO2 emissions (% of total fuel combustion) in United Kingdom?
Give a very brief answer. 14.23. In the year 1983, what is the difference between the CO2 emissions (% of total fuel combustion) in Upper middle income and CO2 emissions (% of total fuel combustion) in United Kingdom?
Provide a succinct answer. 3.83. In the year 1984, what is the difference between the CO2 emissions (% of total fuel combustion) of Low & middle income and CO2 emissions (% of total fuel combustion) of Low income?
Provide a short and direct response. -9.96. In the year 1984, what is the difference between the CO2 emissions (% of total fuel combustion) in Low & middle income and CO2 emissions (% of total fuel combustion) in Upper middle income?
Provide a short and direct response. 0.37. In the year 1984, what is the difference between the CO2 emissions (% of total fuel combustion) of Low & middle income and CO2 emissions (% of total fuel combustion) of United Kingdom?
Offer a very short reply. 3.87. In the year 1984, what is the difference between the CO2 emissions (% of total fuel combustion) in Low income and CO2 emissions (% of total fuel combustion) in Upper middle income?
Make the answer very short. 10.33. In the year 1984, what is the difference between the CO2 emissions (% of total fuel combustion) in Low income and CO2 emissions (% of total fuel combustion) in United Kingdom?
Provide a short and direct response. 13.83. In the year 1984, what is the difference between the CO2 emissions (% of total fuel combustion) in Upper middle income and CO2 emissions (% of total fuel combustion) in United Kingdom?
Ensure brevity in your answer.  3.5. In the year 1985, what is the difference between the CO2 emissions (% of total fuel combustion) in Low & middle income and CO2 emissions (% of total fuel combustion) in Low income?
Give a very brief answer. -10.62. In the year 1985, what is the difference between the CO2 emissions (% of total fuel combustion) of Low & middle income and CO2 emissions (% of total fuel combustion) of Upper middle income?
Your response must be concise. 0.18. In the year 1985, what is the difference between the CO2 emissions (% of total fuel combustion) of Low & middle income and CO2 emissions (% of total fuel combustion) of United Kingdom?
Offer a very short reply. 3.55. In the year 1985, what is the difference between the CO2 emissions (% of total fuel combustion) of Low income and CO2 emissions (% of total fuel combustion) of Upper middle income?
Ensure brevity in your answer.  10.8. In the year 1985, what is the difference between the CO2 emissions (% of total fuel combustion) in Low income and CO2 emissions (% of total fuel combustion) in United Kingdom?
Your answer should be very brief. 14.17. In the year 1985, what is the difference between the CO2 emissions (% of total fuel combustion) in Upper middle income and CO2 emissions (% of total fuel combustion) in United Kingdom?
Make the answer very short. 3.37. What is the ratio of the CO2 emissions (% of total fuel combustion) in Low & middle income in 1979 to that in 1980?
Your response must be concise. 1.07. What is the ratio of the CO2 emissions (% of total fuel combustion) of Upper middle income in 1979 to that in 1980?
Your answer should be compact. 1.02. What is the ratio of the CO2 emissions (% of total fuel combustion) in Low & middle income in 1979 to that in 1981?
Your answer should be very brief. 1.04. What is the ratio of the CO2 emissions (% of total fuel combustion) in Low income in 1979 to that in 1981?
Your answer should be compact. 0.96. What is the ratio of the CO2 emissions (% of total fuel combustion) of Upper middle income in 1979 to that in 1981?
Your answer should be compact. 1.02. What is the ratio of the CO2 emissions (% of total fuel combustion) of Low & middle income in 1979 to that in 1982?
Provide a succinct answer. 1.06. What is the ratio of the CO2 emissions (% of total fuel combustion) of Low income in 1979 to that in 1982?
Your answer should be compact. 1. What is the ratio of the CO2 emissions (% of total fuel combustion) in Upper middle income in 1979 to that in 1982?
Your response must be concise. 1.04. What is the ratio of the CO2 emissions (% of total fuel combustion) of United Kingdom in 1979 to that in 1982?
Give a very brief answer. 0.97. What is the ratio of the CO2 emissions (% of total fuel combustion) of Low & middle income in 1979 to that in 1983?
Give a very brief answer. 1.05. What is the ratio of the CO2 emissions (% of total fuel combustion) in Low income in 1979 to that in 1983?
Your answer should be very brief. 0.96. What is the ratio of the CO2 emissions (% of total fuel combustion) of Upper middle income in 1979 to that in 1983?
Offer a very short reply. 1.05. What is the ratio of the CO2 emissions (% of total fuel combustion) of United Kingdom in 1979 to that in 1983?
Keep it short and to the point. 1.11. What is the ratio of the CO2 emissions (% of total fuel combustion) of Low & middle income in 1979 to that in 1984?
Your response must be concise. 1.06. What is the ratio of the CO2 emissions (% of total fuel combustion) of Low income in 1979 to that in 1984?
Provide a short and direct response. 0.97. What is the ratio of the CO2 emissions (% of total fuel combustion) of Upper middle income in 1979 to that in 1984?
Offer a very short reply. 1.08. What is the ratio of the CO2 emissions (% of total fuel combustion) of United Kingdom in 1979 to that in 1984?
Give a very brief answer. 1.06. What is the ratio of the CO2 emissions (% of total fuel combustion) of Low & middle income in 1979 to that in 1985?
Give a very brief answer. 1.13. What is the ratio of the CO2 emissions (% of total fuel combustion) in Low income in 1979 to that in 1985?
Give a very brief answer. 0.96. What is the ratio of the CO2 emissions (% of total fuel combustion) in Upper middle income in 1979 to that in 1985?
Ensure brevity in your answer.  1.12. What is the ratio of the CO2 emissions (% of total fuel combustion) of United Kingdom in 1979 to that in 1985?
Provide a succinct answer. 1.09. What is the ratio of the CO2 emissions (% of total fuel combustion) in Low & middle income in 1980 to that in 1981?
Your answer should be compact. 0.97. What is the ratio of the CO2 emissions (% of total fuel combustion) of Low income in 1980 to that in 1981?
Give a very brief answer. 0.95. What is the ratio of the CO2 emissions (% of total fuel combustion) in United Kingdom in 1980 to that in 1981?
Your answer should be very brief. 0.99. What is the ratio of the CO2 emissions (% of total fuel combustion) in Low income in 1980 to that in 1982?
Offer a very short reply. 1. What is the ratio of the CO2 emissions (% of total fuel combustion) in Upper middle income in 1980 to that in 1982?
Offer a terse response. 1.01. What is the ratio of the CO2 emissions (% of total fuel combustion) of United Kingdom in 1980 to that in 1982?
Give a very brief answer. 0.98. What is the ratio of the CO2 emissions (% of total fuel combustion) in Low & middle income in 1980 to that in 1983?
Make the answer very short. 0.98. What is the ratio of the CO2 emissions (% of total fuel combustion) of Low income in 1980 to that in 1983?
Your response must be concise. 0.95. What is the ratio of the CO2 emissions (% of total fuel combustion) in Upper middle income in 1980 to that in 1983?
Offer a terse response. 1.02. What is the ratio of the CO2 emissions (% of total fuel combustion) of United Kingdom in 1980 to that in 1983?
Offer a very short reply. 1.11. What is the ratio of the CO2 emissions (% of total fuel combustion) of Low & middle income in 1980 to that in 1984?
Your response must be concise. 0.99. What is the ratio of the CO2 emissions (% of total fuel combustion) of Low income in 1980 to that in 1984?
Provide a short and direct response. 0.97. What is the ratio of the CO2 emissions (% of total fuel combustion) of Upper middle income in 1980 to that in 1984?
Your answer should be very brief. 1.06. What is the ratio of the CO2 emissions (% of total fuel combustion) in United Kingdom in 1980 to that in 1984?
Keep it short and to the point. 1.06. What is the ratio of the CO2 emissions (% of total fuel combustion) of Low & middle income in 1980 to that in 1985?
Provide a succinct answer. 1.06. What is the ratio of the CO2 emissions (% of total fuel combustion) in Low income in 1980 to that in 1985?
Offer a very short reply. 0.95. What is the ratio of the CO2 emissions (% of total fuel combustion) of Upper middle income in 1980 to that in 1985?
Ensure brevity in your answer.  1.09. What is the ratio of the CO2 emissions (% of total fuel combustion) in United Kingdom in 1980 to that in 1985?
Your answer should be very brief. 1.09. What is the ratio of the CO2 emissions (% of total fuel combustion) in Low & middle income in 1981 to that in 1982?
Provide a short and direct response. 1.01. What is the ratio of the CO2 emissions (% of total fuel combustion) in Low income in 1981 to that in 1982?
Offer a very short reply. 1.04. What is the ratio of the CO2 emissions (% of total fuel combustion) of Upper middle income in 1981 to that in 1982?
Give a very brief answer. 1.02. What is the ratio of the CO2 emissions (% of total fuel combustion) of United Kingdom in 1981 to that in 1982?
Your answer should be very brief. 0.98. What is the ratio of the CO2 emissions (% of total fuel combustion) of Low & middle income in 1981 to that in 1983?
Your response must be concise. 1.01. What is the ratio of the CO2 emissions (% of total fuel combustion) of Upper middle income in 1981 to that in 1983?
Ensure brevity in your answer.  1.03. What is the ratio of the CO2 emissions (% of total fuel combustion) in United Kingdom in 1981 to that in 1983?
Offer a very short reply. 1.12. What is the ratio of the CO2 emissions (% of total fuel combustion) in Low & middle income in 1981 to that in 1984?
Provide a short and direct response. 1.02. What is the ratio of the CO2 emissions (% of total fuel combustion) of Low income in 1981 to that in 1984?
Your response must be concise. 1.02. What is the ratio of the CO2 emissions (% of total fuel combustion) in Upper middle income in 1981 to that in 1984?
Ensure brevity in your answer.  1.06. What is the ratio of the CO2 emissions (% of total fuel combustion) in United Kingdom in 1981 to that in 1984?
Keep it short and to the point. 1.07. What is the ratio of the CO2 emissions (% of total fuel combustion) of Low & middle income in 1981 to that in 1985?
Your answer should be very brief. 1.08. What is the ratio of the CO2 emissions (% of total fuel combustion) of Upper middle income in 1981 to that in 1985?
Offer a terse response. 1.1. What is the ratio of the CO2 emissions (% of total fuel combustion) in United Kingdom in 1981 to that in 1985?
Provide a succinct answer. 1.1. What is the ratio of the CO2 emissions (% of total fuel combustion) in Low income in 1982 to that in 1983?
Offer a terse response. 0.96. What is the ratio of the CO2 emissions (% of total fuel combustion) in Upper middle income in 1982 to that in 1983?
Keep it short and to the point. 1.01. What is the ratio of the CO2 emissions (% of total fuel combustion) in United Kingdom in 1982 to that in 1983?
Your response must be concise. 1.14. What is the ratio of the CO2 emissions (% of total fuel combustion) of Low income in 1982 to that in 1984?
Make the answer very short. 0.97. What is the ratio of the CO2 emissions (% of total fuel combustion) in Upper middle income in 1982 to that in 1984?
Provide a short and direct response. 1.04. What is the ratio of the CO2 emissions (% of total fuel combustion) in United Kingdom in 1982 to that in 1984?
Your answer should be compact. 1.09. What is the ratio of the CO2 emissions (% of total fuel combustion) in Low & middle income in 1982 to that in 1985?
Your answer should be very brief. 1.07. What is the ratio of the CO2 emissions (% of total fuel combustion) of Low income in 1982 to that in 1985?
Your answer should be compact. 0.96. What is the ratio of the CO2 emissions (% of total fuel combustion) of Upper middle income in 1982 to that in 1985?
Give a very brief answer. 1.08. What is the ratio of the CO2 emissions (% of total fuel combustion) of United Kingdom in 1982 to that in 1985?
Offer a very short reply. 1.11. What is the ratio of the CO2 emissions (% of total fuel combustion) in Low & middle income in 1983 to that in 1984?
Your answer should be compact. 1.01. What is the ratio of the CO2 emissions (% of total fuel combustion) of Low income in 1983 to that in 1984?
Your answer should be very brief. 1.02. What is the ratio of the CO2 emissions (% of total fuel combustion) of Upper middle income in 1983 to that in 1984?
Provide a succinct answer. 1.03. What is the ratio of the CO2 emissions (% of total fuel combustion) in United Kingdom in 1983 to that in 1984?
Provide a succinct answer. 0.95. What is the ratio of the CO2 emissions (% of total fuel combustion) of Low & middle income in 1983 to that in 1985?
Ensure brevity in your answer.  1.07. What is the ratio of the CO2 emissions (% of total fuel combustion) in Upper middle income in 1983 to that in 1985?
Ensure brevity in your answer.  1.07. What is the ratio of the CO2 emissions (% of total fuel combustion) in United Kingdom in 1983 to that in 1985?
Make the answer very short. 0.98. What is the ratio of the CO2 emissions (% of total fuel combustion) of Low & middle income in 1984 to that in 1985?
Make the answer very short. 1.06. What is the ratio of the CO2 emissions (% of total fuel combustion) of Low income in 1984 to that in 1985?
Offer a terse response. 0.98. What is the ratio of the CO2 emissions (% of total fuel combustion) of Upper middle income in 1984 to that in 1985?
Offer a very short reply. 1.03. What is the ratio of the CO2 emissions (% of total fuel combustion) of United Kingdom in 1984 to that in 1985?
Offer a terse response. 1.02. What is the difference between the highest and the second highest CO2 emissions (% of total fuel combustion) of Low & middle income?
Provide a succinct answer. 0.29. What is the difference between the highest and the second highest CO2 emissions (% of total fuel combustion) of Low income?
Provide a succinct answer. 0.01. What is the difference between the highest and the second highest CO2 emissions (% of total fuel combustion) of Upper middle income?
Your response must be concise. 0.12. What is the difference between the highest and the second highest CO2 emissions (% of total fuel combustion) in United Kingdom?
Your answer should be compact. 0.04. What is the difference between the highest and the lowest CO2 emissions (% of total fuel combustion) of Low & middle income?
Your answer should be very brief. 0.79. What is the difference between the highest and the lowest CO2 emissions (% of total fuel combustion) of Low income?
Your answer should be compact. 0.78. What is the difference between the highest and the lowest CO2 emissions (% of total fuel combustion) in Upper middle income?
Offer a terse response. 0.69. What is the difference between the highest and the lowest CO2 emissions (% of total fuel combustion) in United Kingdom?
Provide a succinct answer. 0.34. 